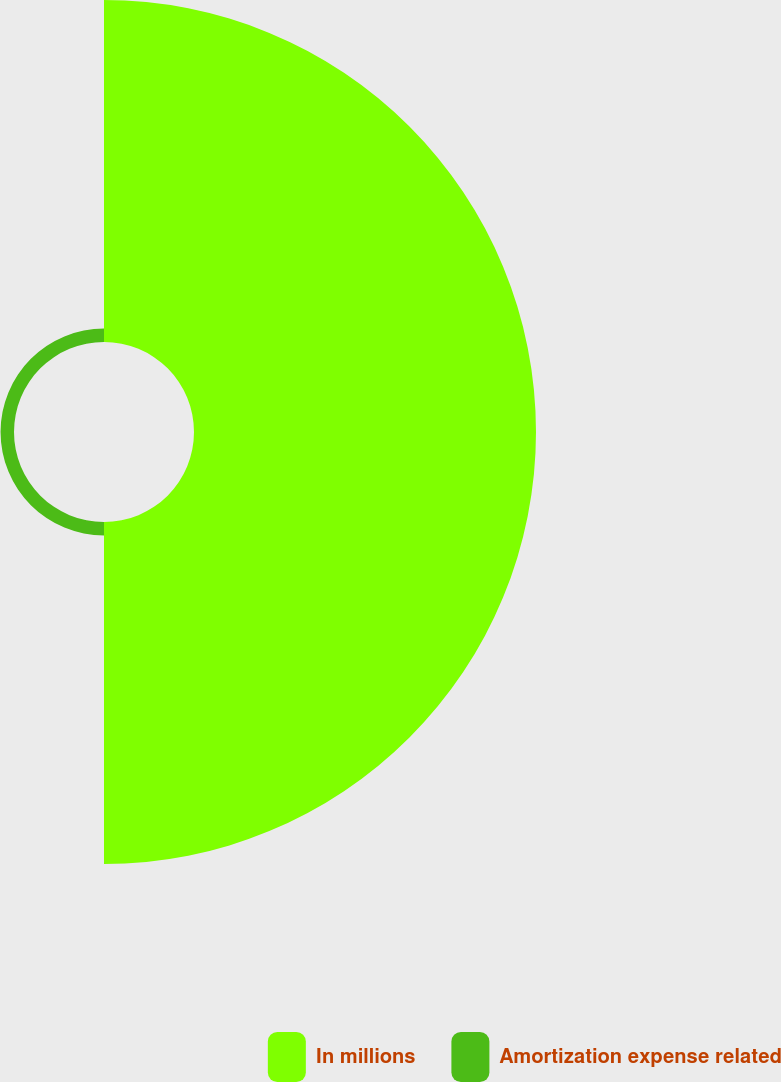<chart> <loc_0><loc_0><loc_500><loc_500><pie_chart><fcel>In millions<fcel>Amortization expense related<nl><fcel>96.22%<fcel>3.78%<nl></chart> 